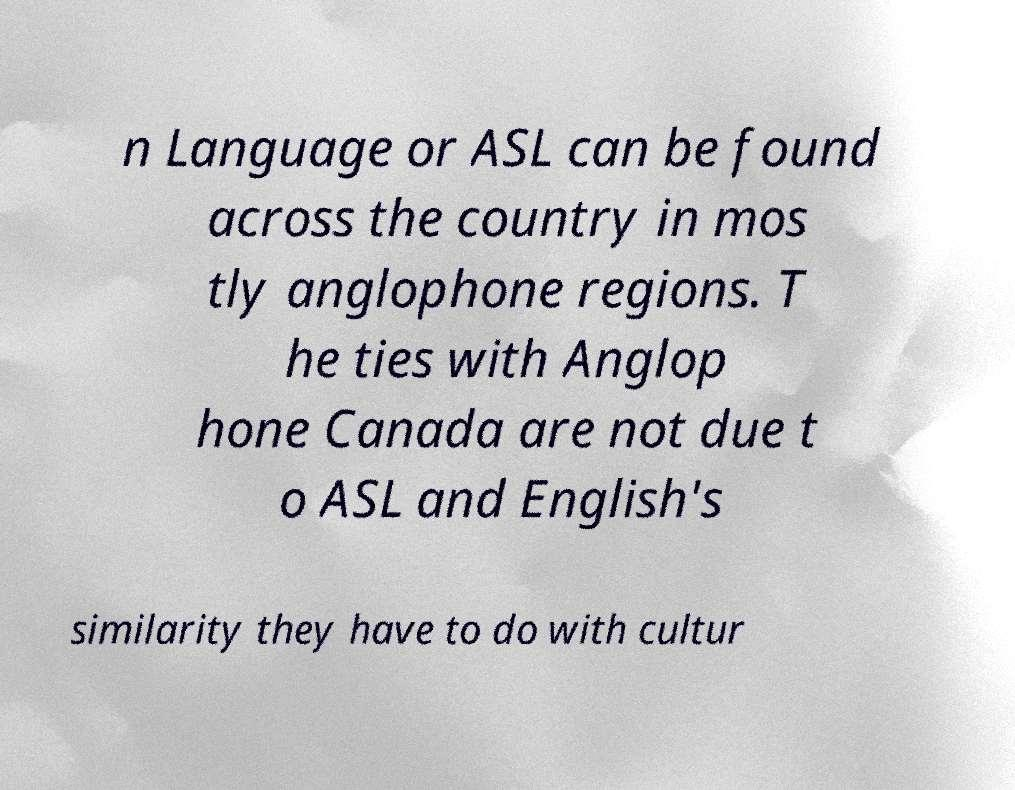Can you accurately transcribe the text from the provided image for me? n Language or ASL can be found across the country in mos tly anglophone regions. T he ties with Anglop hone Canada are not due t o ASL and English's similarity they have to do with cultur 